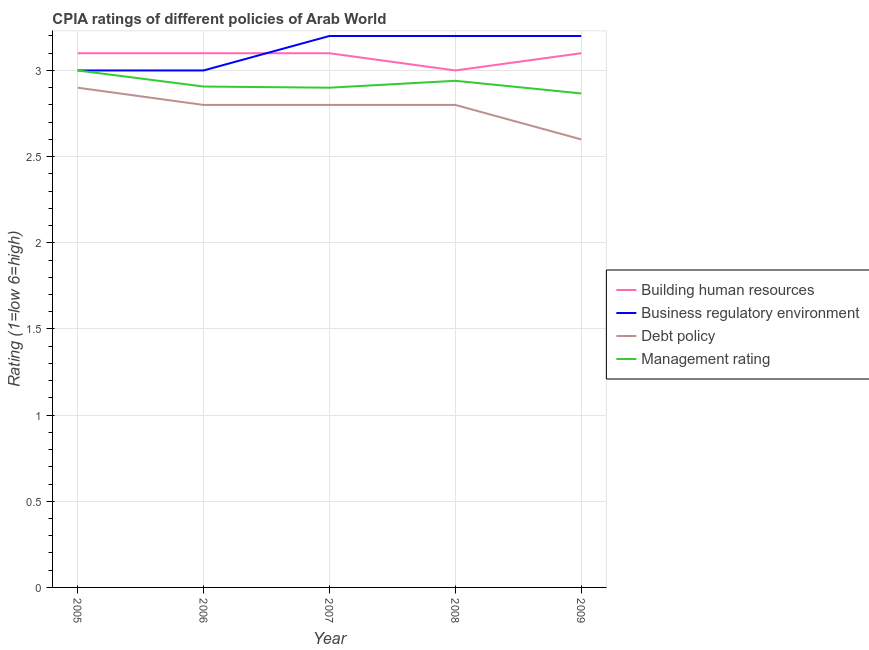How many different coloured lines are there?
Provide a succinct answer. 4. What is the total cpia rating of management in the graph?
Your response must be concise. 14.61. What is the difference between the cpia rating of business regulatory environment in 2007 and the cpia rating of debt policy in 2006?
Give a very brief answer. 0.4. What is the average cpia rating of business regulatory environment per year?
Your answer should be compact. 3.12. In the year 2009, what is the difference between the cpia rating of debt policy and cpia rating of management?
Your answer should be compact. -0.27. What is the ratio of the cpia rating of management in 2005 to that in 2007?
Offer a terse response. 1.03. Is the difference between the cpia rating of business regulatory environment in 2007 and 2008 greater than the difference between the cpia rating of management in 2007 and 2008?
Give a very brief answer. Yes. What is the difference between the highest and the second highest cpia rating of management?
Ensure brevity in your answer.  0.06. What is the difference between the highest and the lowest cpia rating of business regulatory environment?
Keep it short and to the point. 0.2. In how many years, is the cpia rating of debt policy greater than the average cpia rating of debt policy taken over all years?
Provide a succinct answer. 4. Is the cpia rating of building human resources strictly less than the cpia rating of debt policy over the years?
Your answer should be very brief. No. How many years are there in the graph?
Your answer should be very brief. 5. What is the difference between two consecutive major ticks on the Y-axis?
Give a very brief answer. 0.5. Does the graph contain any zero values?
Ensure brevity in your answer.  No. What is the title of the graph?
Provide a succinct answer. CPIA ratings of different policies of Arab World. Does "Oil" appear as one of the legend labels in the graph?
Ensure brevity in your answer.  No. What is the label or title of the X-axis?
Your answer should be very brief. Year. What is the label or title of the Y-axis?
Provide a succinct answer. Rating (1=low 6=high). What is the Rating (1=low 6=high) in Business regulatory environment in 2005?
Provide a short and direct response. 3. What is the Rating (1=low 6=high) of Building human resources in 2006?
Offer a very short reply. 3.1. What is the Rating (1=low 6=high) of Business regulatory environment in 2006?
Make the answer very short. 3. What is the Rating (1=low 6=high) in Debt policy in 2006?
Keep it short and to the point. 2.8. What is the Rating (1=low 6=high) in Management rating in 2006?
Offer a very short reply. 2.91. What is the Rating (1=low 6=high) of Building human resources in 2007?
Ensure brevity in your answer.  3.1. What is the Rating (1=low 6=high) in Business regulatory environment in 2007?
Ensure brevity in your answer.  3.2. What is the Rating (1=low 6=high) of Building human resources in 2008?
Give a very brief answer. 3. What is the Rating (1=low 6=high) in Management rating in 2008?
Your response must be concise. 2.94. What is the Rating (1=low 6=high) of Building human resources in 2009?
Provide a succinct answer. 3.1. What is the Rating (1=low 6=high) of Business regulatory environment in 2009?
Your response must be concise. 3.2. What is the Rating (1=low 6=high) of Debt policy in 2009?
Your answer should be very brief. 2.6. What is the Rating (1=low 6=high) of Management rating in 2009?
Your answer should be very brief. 2.87. Across all years, what is the maximum Rating (1=low 6=high) in Management rating?
Ensure brevity in your answer.  3. Across all years, what is the minimum Rating (1=low 6=high) in Building human resources?
Make the answer very short. 3. Across all years, what is the minimum Rating (1=low 6=high) in Debt policy?
Your answer should be compact. 2.6. Across all years, what is the minimum Rating (1=low 6=high) of Management rating?
Offer a terse response. 2.87. What is the total Rating (1=low 6=high) in Building human resources in the graph?
Your answer should be very brief. 15.4. What is the total Rating (1=low 6=high) of Debt policy in the graph?
Your answer should be very brief. 13.9. What is the total Rating (1=low 6=high) of Management rating in the graph?
Provide a succinct answer. 14.61. What is the difference between the Rating (1=low 6=high) in Debt policy in 2005 and that in 2006?
Your answer should be very brief. 0.1. What is the difference between the Rating (1=low 6=high) of Management rating in 2005 and that in 2006?
Your response must be concise. 0.09. What is the difference between the Rating (1=low 6=high) in Business regulatory environment in 2005 and that in 2007?
Your answer should be compact. -0.2. What is the difference between the Rating (1=low 6=high) of Management rating in 2005 and that in 2007?
Your answer should be very brief. 0.1. What is the difference between the Rating (1=low 6=high) of Management rating in 2005 and that in 2009?
Keep it short and to the point. 0.13. What is the difference between the Rating (1=low 6=high) of Building human resources in 2006 and that in 2007?
Ensure brevity in your answer.  0. What is the difference between the Rating (1=low 6=high) in Management rating in 2006 and that in 2007?
Ensure brevity in your answer.  0.01. What is the difference between the Rating (1=low 6=high) of Building human resources in 2006 and that in 2008?
Ensure brevity in your answer.  0.1. What is the difference between the Rating (1=low 6=high) in Business regulatory environment in 2006 and that in 2008?
Provide a short and direct response. -0.2. What is the difference between the Rating (1=low 6=high) in Debt policy in 2006 and that in 2008?
Offer a very short reply. 0. What is the difference between the Rating (1=low 6=high) of Management rating in 2006 and that in 2008?
Offer a very short reply. -0.03. What is the difference between the Rating (1=low 6=high) in Building human resources in 2006 and that in 2009?
Give a very brief answer. 0. What is the difference between the Rating (1=low 6=high) in Business regulatory environment in 2006 and that in 2009?
Your answer should be compact. -0.2. What is the difference between the Rating (1=low 6=high) of Management rating in 2006 and that in 2009?
Provide a short and direct response. 0.04. What is the difference between the Rating (1=low 6=high) in Building human resources in 2007 and that in 2008?
Your response must be concise. 0.1. What is the difference between the Rating (1=low 6=high) in Management rating in 2007 and that in 2008?
Provide a short and direct response. -0.04. What is the difference between the Rating (1=low 6=high) of Building human resources in 2008 and that in 2009?
Make the answer very short. -0.1. What is the difference between the Rating (1=low 6=high) in Management rating in 2008 and that in 2009?
Your answer should be compact. 0.07. What is the difference between the Rating (1=low 6=high) in Building human resources in 2005 and the Rating (1=low 6=high) in Business regulatory environment in 2006?
Give a very brief answer. 0.1. What is the difference between the Rating (1=low 6=high) of Building human resources in 2005 and the Rating (1=low 6=high) of Management rating in 2006?
Offer a terse response. 0.19. What is the difference between the Rating (1=low 6=high) in Business regulatory environment in 2005 and the Rating (1=low 6=high) in Debt policy in 2006?
Your answer should be very brief. 0.2. What is the difference between the Rating (1=low 6=high) in Business regulatory environment in 2005 and the Rating (1=low 6=high) in Management rating in 2006?
Give a very brief answer. 0.09. What is the difference between the Rating (1=low 6=high) of Debt policy in 2005 and the Rating (1=low 6=high) of Management rating in 2006?
Offer a very short reply. -0.01. What is the difference between the Rating (1=low 6=high) of Building human resources in 2005 and the Rating (1=low 6=high) of Business regulatory environment in 2007?
Your response must be concise. -0.1. What is the difference between the Rating (1=low 6=high) in Building human resources in 2005 and the Rating (1=low 6=high) in Debt policy in 2007?
Your answer should be very brief. 0.3. What is the difference between the Rating (1=low 6=high) in Business regulatory environment in 2005 and the Rating (1=low 6=high) in Management rating in 2007?
Give a very brief answer. 0.1. What is the difference between the Rating (1=low 6=high) of Debt policy in 2005 and the Rating (1=low 6=high) of Management rating in 2007?
Your response must be concise. 0. What is the difference between the Rating (1=low 6=high) in Building human resources in 2005 and the Rating (1=low 6=high) in Debt policy in 2008?
Make the answer very short. 0.3. What is the difference between the Rating (1=low 6=high) in Building human resources in 2005 and the Rating (1=low 6=high) in Management rating in 2008?
Offer a very short reply. 0.16. What is the difference between the Rating (1=low 6=high) of Debt policy in 2005 and the Rating (1=low 6=high) of Management rating in 2008?
Your response must be concise. -0.04. What is the difference between the Rating (1=low 6=high) in Building human resources in 2005 and the Rating (1=low 6=high) in Business regulatory environment in 2009?
Offer a terse response. -0.1. What is the difference between the Rating (1=low 6=high) in Building human resources in 2005 and the Rating (1=low 6=high) in Debt policy in 2009?
Give a very brief answer. 0.5. What is the difference between the Rating (1=low 6=high) in Building human resources in 2005 and the Rating (1=low 6=high) in Management rating in 2009?
Your answer should be compact. 0.23. What is the difference between the Rating (1=low 6=high) in Business regulatory environment in 2005 and the Rating (1=low 6=high) in Management rating in 2009?
Your answer should be very brief. 0.13. What is the difference between the Rating (1=low 6=high) in Building human resources in 2006 and the Rating (1=low 6=high) in Business regulatory environment in 2007?
Ensure brevity in your answer.  -0.1. What is the difference between the Rating (1=low 6=high) in Building human resources in 2006 and the Rating (1=low 6=high) in Management rating in 2007?
Your answer should be very brief. 0.2. What is the difference between the Rating (1=low 6=high) of Business regulatory environment in 2006 and the Rating (1=low 6=high) of Debt policy in 2007?
Your response must be concise. 0.2. What is the difference between the Rating (1=low 6=high) of Business regulatory environment in 2006 and the Rating (1=low 6=high) of Management rating in 2007?
Your answer should be very brief. 0.1. What is the difference between the Rating (1=low 6=high) of Building human resources in 2006 and the Rating (1=low 6=high) of Debt policy in 2008?
Your response must be concise. 0.3. What is the difference between the Rating (1=low 6=high) in Building human resources in 2006 and the Rating (1=low 6=high) in Management rating in 2008?
Offer a terse response. 0.16. What is the difference between the Rating (1=low 6=high) in Business regulatory environment in 2006 and the Rating (1=low 6=high) in Debt policy in 2008?
Give a very brief answer. 0.2. What is the difference between the Rating (1=low 6=high) of Debt policy in 2006 and the Rating (1=low 6=high) of Management rating in 2008?
Offer a very short reply. -0.14. What is the difference between the Rating (1=low 6=high) of Building human resources in 2006 and the Rating (1=low 6=high) of Management rating in 2009?
Ensure brevity in your answer.  0.23. What is the difference between the Rating (1=low 6=high) of Business regulatory environment in 2006 and the Rating (1=low 6=high) of Management rating in 2009?
Keep it short and to the point. 0.13. What is the difference between the Rating (1=low 6=high) of Debt policy in 2006 and the Rating (1=low 6=high) of Management rating in 2009?
Ensure brevity in your answer.  -0.07. What is the difference between the Rating (1=low 6=high) in Building human resources in 2007 and the Rating (1=low 6=high) in Business regulatory environment in 2008?
Provide a succinct answer. -0.1. What is the difference between the Rating (1=low 6=high) of Building human resources in 2007 and the Rating (1=low 6=high) of Management rating in 2008?
Your answer should be compact. 0.16. What is the difference between the Rating (1=low 6=high) in Business regulatory environment in 2007 and the Rating (1=low 6=high) in Debt policy in 2008?
Make the answer very short. 0.4. What is the difference between the Rating (1=low 6=high) of Business regulatory environment in 2007 and the Rating (1=low 6=high) of Management rating in 2008?
Your response must be concise. 0.26. What is the difference between the Rating (1=low 6=high) in Debt policy in 2007 and the Rating (1=low 6=high) in Management rating in 2008?
Give a very brief answer. -0.14. What is the difference between the Rating (1=low 6=high) in Building human resources in 2007 and the Rating (1=low 6=high) in Business regulatory environment in 2009?
Your answer should be compact. -0.1. What is the difference between the Rating (1=low 6=high) of Building human resources in 2007 and the Rating (1=low 6=high) of Management rating in 2009?
Make the answer very short. 0.23. What is the difference between the Rating (1=low 6=high) in Business regulatory environment in 2007 and the Rating (1=low 6=high) in Debt policy in 2009?
Offer a terse response. 0.6. What is the difference between the Rating (1=low 6=high) of Business regulatory environment in 2007 and the Rating (1=low 6=high) of Management rating in 2009?
Offer a terse response. 0.33. What is the difference between the Rating (1=low 6=high) in Debt policy in 2007 and the Rating (1=low 6=high) in Management rating in 2009?
Provide a short and direct response. -0.07. What is the difference between the Rating (1=low 6=high) in Building human resources in 2008 and the Rating (1=low 6=high) in Business regulatory environment in 2009?
Provide a short and direct response. -0.2. What is the difference between the Rating (1=low 6=high) of Building human resources in 2008 and the Rating (1=low 6=high) of Debt policy in 2009?
Your response must be concise. 0.4. What is the difference between the Rating (1=low 6=high) of Building human resources in 2008 and the Rating (1=low 6=high) of Management rating in 2009?
Keep it short and to the point. 0.13. What is the difference between the Rating (1=low 6=high) of Debt policy in 2008 and the Rating (1=low 6=high) of Management rating in 2009?
Provide a succinct answer. -0.07. What is the average Rating (1=low 6=high) in Building human resources per year?
Offer a terse response. 3.08. What is the average Rating (1=low 6=high) in Business regulatory environment per year?
Your answer should be compact. 3.12. What is the average Rating (1=low 6=high) in Debt policy per year?
Your response must be concise. 2.78. What is the average Rating (1=low 6=high) of Management rating per year?
Your answer should be compact. 2.92. In the year 2005, what is the difference between the Rating (1=low 6=high) in Business regulatory environment and Rating (1=low 6=high) in Management rating?
Offer a terse response. 0. In the year 2006, what is the difference between the Rating (1=low 6=high) of Building human resources and Rating (1=low 6=high) of Management rating?
Provide a short and direct response. 0.19. In the year 2006, what is the difference between the Rating (1=low 6=high) in Business regulatory environment and Rating (1=low 6=high) in Debt policy?
Your answer should be compact. 0.2. In the year 2006, what is the difference between the Rating (1=low 6=high) of Business regulatory environment and Rating (1=low 6=high) of Management rating?
Offer a very short reply. 0.09. In the year 2006, what is the difference between the Rating (1=low 6=high) in Debt policy and Rating (1=low 6=high) in Management rating?
Provide a short and direct response. -0.11. In the year 2007, what is the difference between the Rating (1=low 6=high) of Building human resources and Rating (1=low 6=high) of Business regulatory environment?
Offer a terse response. -0.1. In the year 2007, what is the difference between the Rating (1=low 6=high) of Building human resources and Rating (1=low 6=high) of Debt policy?
Keep it short and to the point. 0.3. In the year 2007, what is the difference between the Rating (1=low 6=high) in Business regulatory environment and Rating (1=low 6=high) in Debt policy?
Keep it short and to the point. 0.4. In the year 2008, what is the difference between the Rating (1=low 6=high) of Building human resources and Rating (1=low 6=high) of Business regulatory environment?
Offer a very short reply. -0.2. In the year 2008, what is the difference between the Rating (1=low 6=high) of Building human resources and Rating (1=low 6=high) of Debt policy?
Offer a very short reply. 0.2. In the year 2008, what is the difference between the Rating (1=low 6=high) of Business regulatory environment and Rating (1=low 6=high) of Management rating?
Ensure brevity in your answer.  0.26. In the year 2008, what is the difference between the Rating (1=low 6=high) in Debt policy and Rating (1=low 6=high) in Management rating?
Give a very brief answer. -0.14. In the year 2009, what is the difference between the Rating (1=low 6=high) in Building human resources and Rating (1=low 6=high) in Management rating?
Ensure brevity in your answer.  0.23. In the year 2009, what is the difference between the Rating (1=low 6=high) in Business regulatory environment and Rating (1=low 6=high) in Debt policy?
Provide a succinct answer. 0.6. In the year 2009, what is the difference between the Rating (1=low 6=high) of Debt policy and Rating (1=low 6=high) of Management rating?
Keep it short and to the point. -0.27. What is the ratio of the Rating (1=low 6=high) of Debt policy in 2005 to that in 2006?
Give a very brief answer. 1.04. What is the ratio of the Rating (1=low 6=high) in Management rating in 2005 to that in 2006?
Give a very brief answer. 1.03. What is the ratio of the Rating (1=low 6=high) of Business regulatory environment in 2005 to that in 2007?
Make the answer very short. 0.94. What is the ratio of the Rating (1=low 6=high) in Debt policy in 2005 to that in 2007?
Make the answer very short. 1.04. What is the ratio of the Rating (1=low 6=high) in Management rating in 2005 to that in 2007?
Give a very brief answer. 1.03. What is the ratio of the Rating (1=low 6=high) in Building human resources in 2005 to that in 2008?
Provide a succinct answer. 1.03. What is the ratio of the Rating (1=low 6=high) of Business regulatory environment in 2005 to that in 2008?
Your answer should be very brief. 0.94. What is the ratio of the Rating (1=low 6=high) of Debt policy in 2005 to that in 2008?
Provide a short and direct response. 1.04. What is the ratio of the Rating (1=low 6=high) of Management rating in 2005 to that in 2008?
Keep it short and to the point. 1.02. What is the ratio of the Rating (1=low 6=high) in Building human resources in 2005 to that in 2009?
Ensure brevity in your answer.  1. What is the ratio of the Rating (1=low 6=high) of Debt policy in 2005 to that in 2009?
Keep it short and to the point. 1.12. What is the ratio of the Rating (1=low 6=high) in Management rating in 2005 to that in 2009?
Ensure brevity in your answer.  1.05. What is the ratio of the Rating (1=low 6=high) of Building human resources in 2006 to that in 2007?
Keep it short and to the point. 1. What is the ratio of the Rating (1=low 6=high) of Building human resources in 2006 to that in 2008?
Keep it short and to the point. 1.03. What is the ratio of the Rating (1=low 6=high) in Management rating in 2006 to that in 2008?
Offer a very short reply. 0.99. What is the ratio of the Rating (1=low 6=high) of Building human resources in 2006 to that in 2009?
Give a very brief answer. 1. What is the ratio of the Rating (1=low 6=high) in Debt policy in 2006 to that in 2009?
Your answer should be compact. 1.08. What is the ratio of the Rating (1=low 6=high) in Management rating in 2006 to that in 2009?
Make the answer very short. 1.01. What is the ratio of the Rating (1=low 6=high) of Building human resources in 2007 to that in 2008?
Offer a very short reply. 1.03. What is the ratio of the Rating (1=low 6=high) in Business regulatory environment in 2007 to that in 2008?
Provide a short and direct response. 1. What is the ratio of the Rating (1=low 6=high) in Debt policy in 2007 to that in 2008?
Make the answer very short. 1. What is the ratio of the Rating (1=low 6=high) in Management rating in 2007 to that in 2008?
Provide a short and direct response. 0.99. What is the ratio of the Rating (1=low 6=high) of Building human resources in 2007 to that in 2009?
Ensure brevity in your answer.  1. What is the ratio of the Rating (1=low 6=high) of Management rating in 2007 to that in 2009?
Your answer should be compact. 1.01. What is the ratio of the Rating (1=low 6=high) of Business regulatory environment in 2008 to that in 2009?
Keep it short and to the point. 1. What is the ratio of the Rating (1=low 6=high) of Management rating in 2008 to that in 2009?
Your answer should be very brief. 1.03. What is the difference between the highest and the second highest Rating (1=low 6=high) in Building human resources?
Your response must be concise. 0. What is the difference between the highest and the second highest Rating (1=low 6=high) of Business regulatory environment?
Give a very brief answer. 0. What is the difference between the highest and the lowest Rating (1=low 6=high) of Business regulatory environment?
Your response must be concise. 0.2. What is the difference between the highest and the lowest Rating (1=low 6=high) of Debt policy?
Your answer should be compact. 0.3. What is the difference between the highest and the lowest Rating (1=low 6=high) in Management rating?
Offer a very short reply. 0.13. 